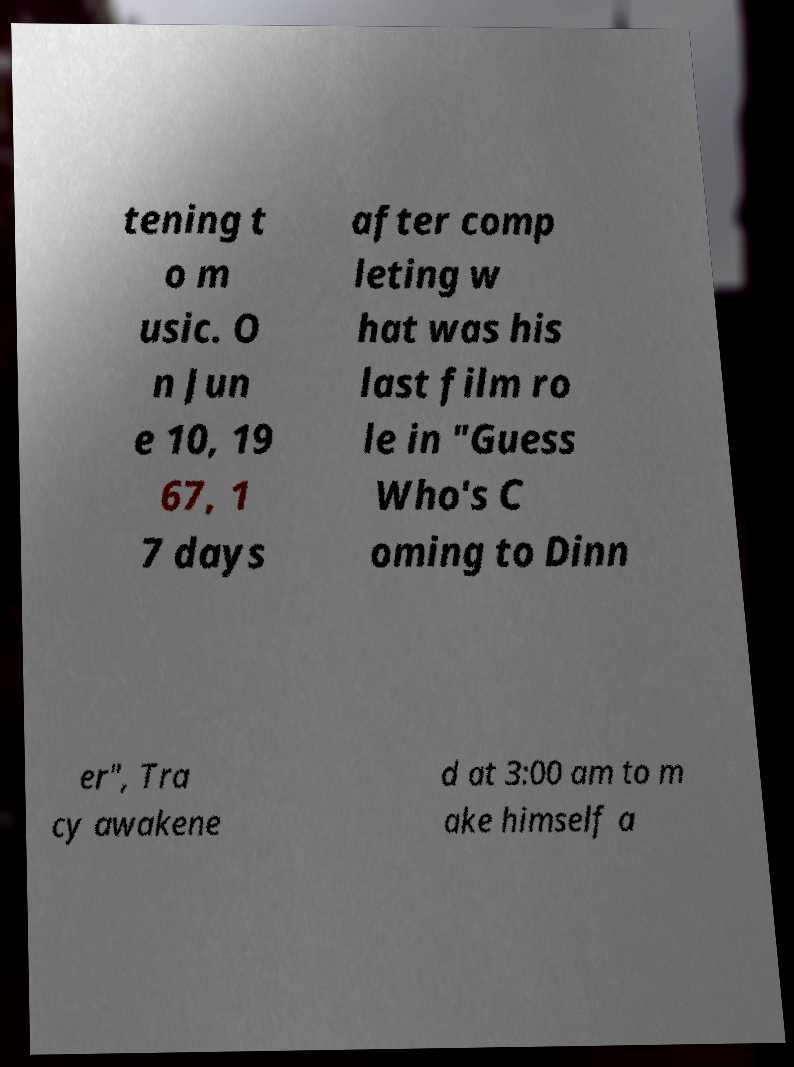There's text embedded in this image that I need extracted. Can you transcribe it verbatim? tening t o m usic. O n Jun e 10, 19 67, 1 7 days after comp leting w hat was his last film ro le in "Guess Who's C oming to Dinn er", Tra cy awakene d at 3:00 am to m ake himself a 